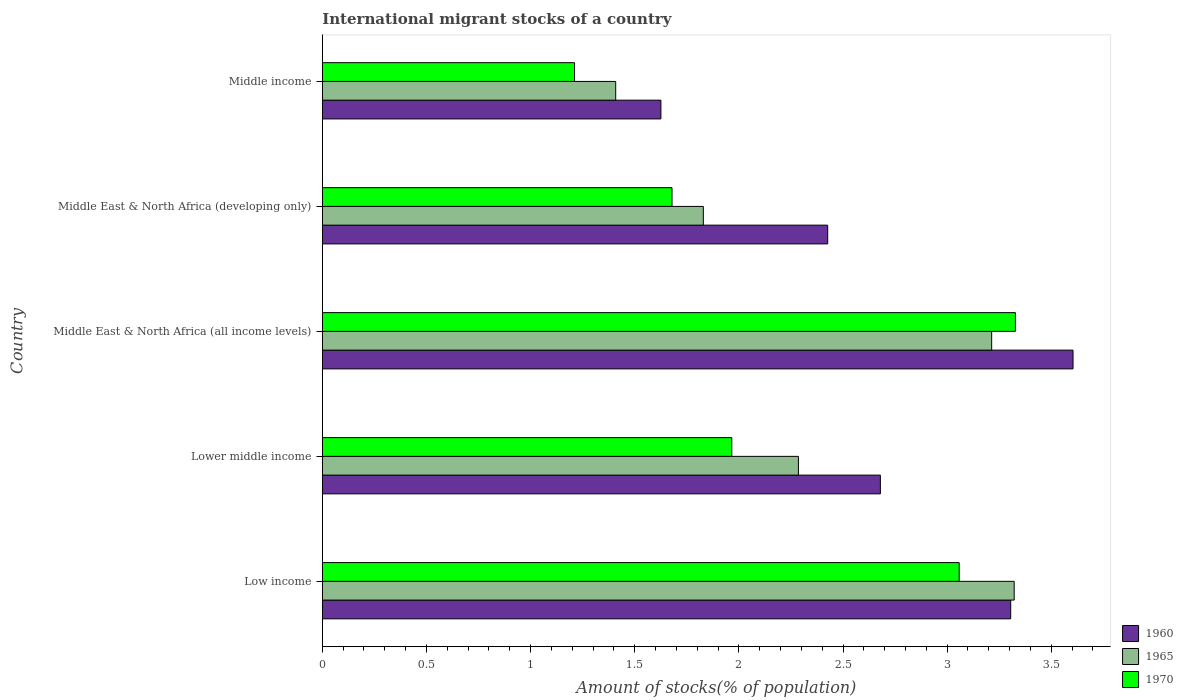How many bars are there on the 5th tick from the top?
Ensure brevity in your answer.  3. How many bars are there on the 2nd tick from the bottom?
Offer a terse response. 3. What is the label of the 2nd group of bars from the top?
Your answer should be compact. Middle East & North Africa (developing only). What is the amount of stocks in in 1965 in Low income?
Ensure brevity in your answer.  3.32. Across all countries, what is the maximum amount of stocks in in 1965?
Ensure brevity in your answer.  3.32. Across all countries, what is the minimum amount of stocks in in 1970?
Keep it short and to the point. 1.21. In which country was the amount of stocks in in 1965 maximum?
Ensure brevity in your answer.  Low income. In which country was the amount of stocks in in 1970 minimum?
Provide a short and direct response. Middle income. What is the total amount of stocks in in 1970 in the graph?
Make the answer very short. 11.24. What is the difference between the amount of stocks in in 1960 in Lower middle income and that in Middle income?
Your answer should be very brief. 1.05. What is the difference between the amount of stocks in in 1965 in Middle income and the amount of stocks in in 1960 in Lower middle income?
Your response must be concise. -1.27. What is the average amount of stocks in in 1965 per country?
Your answer should be very brief. 2.41. What is the difference between the amount of stocks in in 1960 and amount of stocks in in 1965 in Middle East & North Africa (developing only)?
Your answer should be very brief. 0.6. In how many countries, is the amount of stocks in in 1960 greater than 2 %?
Offer a very short reply. 4. What is the ratio of the amount of stocks in in 1970 in Low income to that in Middle income?
Your answer should be very brief. 2.53. Is the amount of stocks in in 1960 in Middle East & North Africa (developing only) less than that in Middle income?
Ensure brevity in your answer.  No. What is the difference between the highest and the second highest amount of stocks in in 1970?
Your answer should be compact. 0.27. What is the difference between the highest and the lowest amount of stocks in in 1960?
Offer a terse response. 1.98. Is the sum of the amount of stocks in in 1960 in Low income and Middle East & North Africa (all income levels) greater than the maximum amount of stocks in in 1970 across all countries?
Give a very brief answer. Yes. What does the 2nd bar from the top in Lower middle income represents?
Make the answer very short. 1965. What does the 1st bar from the bottom in Lower middle income represents?
Offer a very short reply. 1960. How many bars are there?
Provide a succinct answer. 15. Are all the bars in the graph horizontal?
Ensure brevity in your answer.  Yes. How many countries are there in the graph?
Provide a succinct answer. 5. What is the difference between two consecutive major ticks on the X-axis?
Keep it short and to the point. 0.5. Does the graph contain any zero values?
Provide a succinct answer. No. How many legend labels are there?
Your answer should be compact. 3. How are the legend labels stacked?
Make the answer very short. Vertical. What is the title of the graph?
Provide a succinct answer. International migrant stocks of a country. Does "1974" appear as one of the legend labels in the graph?
Offer a terse response. No. What is the label or title of the X-axis?
Ensure brevity in your answer.  Amount of stocks(% of population). What is the label or title of the Y-axis?
Your answer should be very brief. Country. What is the Amount of stocks(% of population) of 1960 in Low income?
Your response must be concise. 3.31. What is the Amount of stocks(% of population) of 1965 in Low income?
Offer a terse response. 3.32. What is the Amount of stocks(% of population) in 1970 in Low income?
Offer a terse response. 3.06. What is the Amount of stocks(% of population) in 1960 in Lower middle income?
Ensure brevity in your answer.  2.68. What is the Amount of stocks(% of population) of 1965 in Lower middle income?
Provide a succinct answer. 2.29. What is the Amount of stocks(% of population) of 1970 in Lower middle income?
Ensure brevity in your answer.  1.97. What is the Amount of stocks(% of population) in 1960 in Middle East & North Africa (all income levels)?
Your response must be concise. 3.6. What is the Amount of stocks(% of population) of 1965 in Middle East & North Africa (all income levels)?
Make the answer very short. 3.21. What is the Amount of stocks(% of population) in 1970 in Middle East & North Africa (all income levels)?
Your response must be concise. 3.33. What is the Amount of stocks(% of population) in 1960 in Middle East & North Africa (developing only)?
Keep it short and to the point. 2.43. What is the Amount of stocks(% of population) in 1965 in Middle East & North Africa (developing only)?
Give a very brief answer. 1.83. What is the Amount of stocks(% of population) in 1970 in Middle East & North Africa (developing only)?
Your answer should be compact. 1.68. What is the Amount of stocks(% of population) in 1960 in Middle income?
Give a very brief answer. 1.63. What is the Amount of stocks(% of population) of 1965 in Middle income?
Make the answer very short. 1.41. What is the Amount of stocks(% of population) in 1970 in Middle income?
Give a very brief answer. 1.21. Across all countries, what is the maximum Amount of stocks(% of population) in 1960?
Provide a succinct answer. 3.6. Across all countries, what is the maximum Amount of stocks(% of population) of 1965?
Your answer should be very brief. 3.32. Across all countries, what is the maximum Amount of stocks(% of population) of 1970?
Give a very brief answer. 3.33. Across all countries, what is the minimum Amount of stocks(% of population) of 1960?
Make the answer very short. 1.63. Across all countries, what is the minimum Amount of stocks(% of population) of 1965?
Keep it short and to the point. 1.41. Across all countries, what is the minimum Amount of stocks(% of population) of 1970?
Provide a short and direct response. 1.21. What is the total Amount of stocks(% of population) of 1960 in the graph?
Provide a short and direct response. 13.64. What is the total Amount of stocks(% of population) in 1965 in the graph?
Your answer should be compact. 12.06. What is the total Amount of stocks(% of population) in 1970 in the graph?
Keep it short and to the point. 11.24. What is the difference between the Amount of stocks(% of population) of 1960 in Low income and that in Lower middle income?
Offer a very short reply. 0.63. What is the difference between the Amount of stocks(% of population) in 1965 in Low income and that in Lower middle income?
Offer a terse response. 1.04. What is the difference between the Amount of stocks(% of population) of 1970 in Low income and that in Lower middle income?
Ensure brevity in your answer.  1.09. What is the difference between the Amount of stocks(% of population) in 1960 in Low income and that in Middle East & North Africa (all income levels)?
Keep it short and to the point. -0.3. What is the difference between the Amount of stocks(% of population) in 1965 in Low income and that in Middle East & North Africa (all income levels)?
Ensure brevity in your answer.  0.11. What is the difference between the Amount of stocks(% of population) in 1970 in Low income and that in Middle East & North Africa (all income levels)?
Keep it short and to the point. -0.27. What is the difference between the Amount of stocks(% of population) in 1960 in Low income and that in Middle East & North Africa (developing only)?
Your answer should be very brief. 0.88. What is the difference between the Amount of stocks(% of population) of 1965 in Low income and that in Middle East & North Africa (developing only)?
Your answer should be very brief. 1.49. What is the difference between the Amount of stocks(% of population) in 1970 in Low income and that in Middle East & North Africa (developing only)?
Offer a very short reply. 1.38. What is the difference between the Amount of stocks(% of population) in 1960 in Low income and that in Middle income?
Give a very brief answer. 1.68. What is the difference between the Amount of stocks(% of population) of 1965 in Low income and that in Middle income?
Make the answer very short. 1.91. What is the difference between the Amount of stocks(% of population) of 1970 in Low income and that in Middle income?
Your answer should be compact. 1.85. What is the difference between the Amount of stocks(% of population) of 1960 in Lower middle income and that in Middle East & North Africa (all income levels)?
Offer a terse response. -0.93. What is the difference between the Amount of stocks(% of population) in 1965 in Lower middle income and that in Middle East & North Africa (all income levels)?
Ensure brevity in your answer.  -0.93. What is the difference between the Amount of stocks(% of population) of 1970 in Lower middle income and that in Middle East & North Africa (all income levels)?
Offer a very short reply. -1.36. What is the difference between the Amount of stocks(% of population) in 1960 in Lower middle income and that in Middle East & North Africa (developing only)?
Provide a succinct answer. 0.25. What is the difference between the Amount of stocks(% of population) in 1965 in Lower middle income and that in Middle East & North Africa (developing only)?
Give a very brief answer. 0.46. What is the difference between the Amount of stocks(% of population) of 1970 in Lower middle income and that in Middle East & North Africa (developing only)?
Keep it short and to the point. 0.29. What is the difference between the Amount of stocks(% of population) in 1960 in Lower middle income and that in Middle income?
Give a very brief answer. 1.05. What is the difference between the Amount of stocks(% of population) in 1965 in Lower middle income and that in Middle income?
Make the answer very short. 0.88. What is the difference between the Amount of stocks(% of population) in 1970 in Lower middle income and that in Middle income?
Offer a terse response. 0.76. What is the difference between the Amount of stocks(% of population) in 1960 in Middle East & North Africa (all income levels) and that in Middle East & North Africa (developing only)?
Your answer should be compact. 1.18. What is the difference between the Amount of stocks(% of population) of 1965 in Middle East & North Africa (all income levels) and that in Middle East & North Africa (developing only)?
Offer a very short reply. 1.38. What is the difference between the Amount of stocks(% of population) of 1970 in Middle East & North Africa (all income levels) and that in Middle East & North Africa (developing only)?
Give a very brief answer. 1.65. What is the difference between the Amount of stocks(% of population) of 1960 in Middle East & North Africa (all income levels) and that in Middle income?
Give a very brief answer. 1.98. What is the difference between the Amount of stocks(% of population) in 1965 in Middle East & North Africa (all income levels) and that in Middle income?
Offer a very short reply. 1.81. What is the difference between the Amount of stocks(% of population) in 1970 in Middle East & North Africa (all income levels) and that in Middle income?
Ensure brevity in your answer.  2.12. What is the difference between the Amount of stocks(% of population) in 1960 in Middle East & North Africa (developing only) and that in Middle income?
Your response must be concise. 0.8. What is the difference between the Amount of stocks(% of population) in 1965 in Middle East & North Africa (developing only) and that in Middle income?
Your answer should be compact. 0.42. What is the difference between the Amount of stocks(% of population) in 1970 in Middle East & North Africa (developing only) and that in Middle income?
Provide a succinct answer. 0.47. What is the difference between the Amount of stocks(% of population) in 1960 in Low income and the Amount of stocks(% of population) in 1965 in Lower middle income?
Offer a very short reply. 1.02. What is the difference between the Amount of stocks(% of population) in 1960 in Low income and the Amount of stocks(% of population) in 1970 in Lower middle income?
Your answer should be very brief. 1.34. What is the difference between the Amount of stocks(% of population) in 1965 in Low income and the Amount of stocks(% of population) in 1970 in Lower middle income?
Provide a succinct answer. 1.36. What is the difference between the Amount of stocks(% of population) of 1960 in Low income and the Amount of stocks(% of population) of 1965 in Middle East & North Africa (all income levels)?
Provide a succinct answer. 0.09. What is the difference between the Amount of stocks(% of population) of 1960 in Low income and the Amount of stocks(% of population) of 1970 in Middle East & North Africa (all income levels)?
Offer a very short reply. -0.02. What is the difference between the Amount of stocks(% of population) of 1965 in Low income and the Amount of stocks(% of population) of 1970 in Middle East & North Africa (all income levels)?
Give a very brief answer. -0.01. What is the difference between the Amount of stocks(% of population) in 1960 in Low income and the Amount of stocks(% of population) in 1965 in Middle East & North Africa (developing only)?
Provide a succinct answer. 1.48. What is the difference between the Amount of stocks(% of population) in 1960 in Low income and the Amount of stocks(% of population) in 1970 in Middle East & North Africa (developing only)?
Provide a succinct answer. 1.63. What is the difference between the Amount of stocks(% of population) of 1965 in Low income and the Amount of stocks(% of population) of 1970 in Middle East & North Africa (developing only)?
Keep it short and to the point. 1.64. What is the difference between the Amount of stocks(% of population) in 1960 in Low income and the Amount of stocks(% of population) in 1965 in Middle income?
Provide a succinct answer. 1.9. What is the difference between the Amount of stocks(% of population) of 1960 in Low income and the Amount of stocks(% of population) of 1970 in Middle income?
Offer a terse response. 2.09. What is the difference between the Amount of stocks(% of population) in 1965 in Low income and the Amount of stocks(% of population) in 1970 in Middle income?
Provide a short and direct response. 2.11. What is the difference between the Amount of stocks(% of population) in 1960 in Lower middle income and the Amount of stocks(% of population) in 1965 in Middle East & North Africa (all income levels)?
Your answer should be very brief. -0.53. What is the difference between the Amount of stocks(% of population) of 1960 in Lower middle income and the Amount of stocks(% of population) of 1970 in Middle East & North Africa (all income levels)?
Provide a short and direct response. -0.65. What is the difference between the Amount of stocks(% of population) in 1965 in Lower middle income and the Amount of stocks(% of population) in 1970 in Middle East & North Africa (all income levels)?
Keep it short and to the point. -1.04. What is the difference between the Amount of stocks(% of population) of 1960 in Lower middle income and the Amount of stocks(% of population) of 1965 in Middle East & North Africa (developing only)?
Keep it short and to the point. 0.85. What is the difference between the Amount of stocks(% of population) in 1960 in Lower middle income and the Amount of stocks(% of population) in 1970 in Middle East & North Africa (developing only)?
Your response must be concise. 1. What is the difference between the Amount of stocks(% of population) in 1965 in Lower middle income and the Amount of stocks(% of population) in 1970 in Middle East & North Africa (developing only)?
Provide a succinct answer. 0.61. What is the difference between the Amount of stocks(% of population) of 1960 in Lower middle income and the Amount of stocks(% of population) of 1965 in Middle income?
Make the answer very short. 1.27. What is the difference between the Amount of stocks(% of population) in 1960 in Lower middle income and the Amount of stocks(% of population) in 1970 in Middle income?
Ensure brevity in your answer.  1.47. What is the difference between the Amount of stocks(% of population) in 1965 in Lower middle income and the Amount of stocks(% of population) in 1970 in Middle income?
Your response must be concise. 1.07. What is the difference between the Amount of stocks(% of population) of 1960 in Middle East & North Africa (all income levels) and the Amount of stocks(% of population) of 1965 in Middle East & North Africa (developing only)?
Provide a short and direct response. 1.78. What is the difference between the Amount of stocks(% of population) of 1960 in Middle East & North Africa (all income levels) and the Amount of stocks(% of population) of 1970 in Middle East & North Africa (developing only)?
Provide a succinct answer. 1.93. What is the difference between the Amount of stocks(% of population) in 1965 in Middle East & North Africa (all income levels) and the Amount of stocks(% of population) in 1970 in Middle East & North Africa (developing only)?
Offer a terse response. 1.53. What is the difference between the Amount of stocks(% of population) of 1960 in Middle East & North Africa (all income levels) and the Amount of stocks(% of population) of 1965 in Middle income?
Keep it short and to the point. 2.2. What is the difference between the Amount of stocks(% of population) in 1960 in Middle East & North Africa (all income levels) and the Amount of stocks(% of population) in 1970 in Middle income?
Offer a very short reply. 2.39. What is the difference between the Amount of stocks(% of population) of 1965 in Middle East & North Africa (all income levels) and the Amount of stocks(% of population) of 1970 in Middle income?
Your answer should be compact. 2. What is the difference between the Amount of stocks(% of population) in 1960 in Middle East & North Africa (developing only) and the Amount of stocks(% of population) in 1970 in Middle income?
Your response must be concise. 1.22. What is the difference between the Amount of stocks(% of population) of 1965 in Middle East & North Africa (developing only) and the Amount of stocks(% of population) of 1970 in Middle income?
Offer a very short reply. 0.62. What is the average Amount of stocks(% of population) in 1960 per country?
Ensure brevity in your answer.  2.73. What is the average Amount of stocks(% of population) in 1965 per country?
Offer a very short reply. 2.41. What is the average Amount of stocks(% of population) of 1970 per country?
Your response must be concise. 2.25. What is the difference between the Amount of stocks(% of population) of 1960 and Amount of stocks(% of population) of 1965 in Low income?
Offer a very short reply. -0.02. What is the difference between the Amount of stocks(% of population) of 1960 and Amount of stocks(% of population) of 1970 in Low income?
Make the answer very short. 0.25. What is the difference between the Amount of stocks(% of population) in 1965 and Amount of stocks(% of population) in 1970 in Low income?
Make the answer very short. 0.26. What is the difference between the Amount of stocks(% of population) of 1960 and Amount of stocks(% of population) of 1965 in Lower middle income?
Offer a very short reply. 0.39. What is the difference between the Amount of stocks(% of population) of 1960 and Amount of stocks(% of population) of 1970 in Lower middle income?
Keep it short and to the point. 0.71. What is the difference between the Amount of stocks(% of population) of 1965 and Amount of stocks(% of population) of 1970 in Lower middle income?
Offer a terse response. 0.32. What is the difference between the Amount of stocks(% of population) in 1960 and Amount of stocks(% of population) in 1965 in Middle East & North Africa (all income levels)?
Provide a short and direct response. 0.39. What is the difference between the Amount of stocks(% of population) of 1960 and Amount of stocks(% of population) of 1970 in Middle East & North Africa (all income levels)?
Offer a very short reply. 0.28. What is the difference between the Amount of stocks(% of population) of 1965 and Amount of stocks(% of population) of 1970 in Middle East & North Africa (all income levels)?
Offer a terse response. -0.11. What is the difference between the Amount of stocks(% of population) of 1960 and Amount of stocks(% of population) of 1965 in Middle East & North Africa (developing only)?
Make the answer very short. 0.6. What is the difference between the Amount of stocks(% of population) of 1960 and Amount of stocks(% of population) of 1970 in Middle East & North Africa (developing only)?
Keep it short and to the point. 0.75. What is the difference between the Amount of stocks(% of population) in 1965 and Amount of stocks(% of population) in 1970 in Middle East & North Africa (developing only)?
Provide a short and direct response. 0.15. What is the difference between the Amount of stocks(% of population) in 1960 and Amount of stocks(% of population) in 1965 in Middle income?
Make the answer very short. 0.22. What is the difference between the Amount of stocks(% of population) in 1960 and Amount of stocks(% of population) in 1970 in Middle income?
Make the answer very short. 0.41. What is the difference between the Amount of stocks(% of population) in 1965 and Amount of stocks(% of population) in 1970 in Middle income?
Keep it short and to the point. 0.2. What is the ratio of the Amount of stocks(% of population) in 1960 in Low income to that in Lower middle income?
Provide a short and direct response. 1.23. What is the ratio of the Amount of stocks(% of population) in 1965 in Low income to that in Lower middle income?
Provide a succinct answer. 1.45. What is the ratio of the Amount of stocks(% of population) of 1970 in Low income to that in Lower middle income?
Your answer should be very brief. 1.56. What is the ratio of the Amount of stocks(% of population) in 1960 in Low income to that in Middle East & North Africa (all income levels)?
Offer a very short reply. 0.92. What is the ratio of the Amount of stocks(% of population) of 1965 in Low income to that in Middle East & North Africa (all income levels)?
Provide a short and direct response. 1.03. What is the ratio of the Amount of stocks(% of population) of 1970 in Low income to that in Middle East & North Africa (all income levels)?
Your response must be concise. 0.92. What is the ratio of the Amount of stocks(% of population) in 1960 in Low income to that in Middle East & North Africa (developing only)?
Make the answer very short. 1.36. What is the ratio of the Amount of stocks(% of population) of 1965 in Low income to that in Middle East & North Africa (developing only)?
Offer a terse response. 1.82. What is the ratio of the Amount of stocks(% of population) of 1970 in Low income to that in Middle East & North Africa (developing only)?
Make the answer very short. 1.82. What is the ratio of the Amount of stocks(% of population) of 1960 in Low income to that in Middle income?
Your response must be concise. 2.03. What is the ratio of the Amount of stocks(% of population) of 1965 in Low income to that in Middle income?
Your response must be concise. 2.36. What is the ratio of the Amount of stocks(% of population) in 1970 in Low income to that in Middle income?
Your response must be concise. 2.52. What is the ratio of the Amount of stocks(% of population) of 1960 in Lower middle income to that in Middle East & North Africa (all income levels)?
Make the answer very short. 0.74. What is the ratio of the Amount of stocks(% of population) in 1965 in Lower middle income to that in Middle East & North Africa (all income levels)?
Keep it short and to the point. 0.71. What is the ratio of the Amount of stocks(% of population) of 1970 in Lower middle income to that in Middle East & North Africa (all income levels)?
Keep it short and to the point. 0.59. What is the ratio of the Amount of stocks(% of population) of 1960 in Lower middle income to that in Middle East & North Africa (developing only)?
Give a very brief answer. 1.1. What is the ratio of the Amount of stocks(% of population) in 1965 in Lower middle income to that in Middle East & North Africa (developing only)?
Give a very brief answer. 1.25. What is the ratio of the Amount of stocks(% of population) in 1970 in Lower middle income to that in Middle East & North Africa (developing only)?
Offer a terse response. 1.17. What is the ratio of the Amount of stocks(% of population) in 1960 in Lower middle income to that in Middle income?
Ensure brevity in your answer.  1.65. What is the ratio of the Amount of stocks(% of population) of 1965 in Lower middle income to that in Middle income?
Provide a short and direct response. 1.62. What is the ratio of the Amount of stocks(% of population) of 1970 in Lower middle income to that in Middle income?
Provide a short and direct response. 1.62. What is the ratio of the Amount of stocks(% of population) of 1960 in Middle East & North Africa (all income levels) to that in Middle East & North Africa (developing only)?
Offer a very short reply. 1.49. What is the ratio of the Amount of stocks(% of population) of 1965 in Middle East & North Africa (all income levels) to that in Middle East & North Africa (developing only)?
Your answer should be very brief. 1.76. What is the ratio of the Amount of stocks(% of population) in 1970 in Middle East & North Africa (all income levels) to that in Middle East & North Africa (developing only)?
Provide a short and direct response. 1.98. What is the ratio of the Amount of stocks(% of population) of 1960 in Middle East & North Africa (all income levels) to that in Middle income?
Your response must be concise. 2.22. What is the ratio of the Amount of stocks(% of population) of 1965 in Middle East & North Africa (all income levels) to that in Middle income?
Offer a terse response. 2.28. What is the ratio of the Amount of stocks(% of population) in 1970 in Middle East & North Africa (all income levels) to that in Middle income?
Provide a short and direct response. 2.75. What is the ratio of the Amount of stocks(% of population) of 1960 in Middle East & North Africa (developing only) to that in Middle income?
Provide a succinct answer. 1.49. What is the ratio of the Amount of stocks(% of population) of 1965 in Middle East & North Africa (developing only) to that in Middle income?
Your answer should be compact. 1.3. What is the ratio of the Amount of stocks(% of population) in 1970 in Middle East & North Africa (developing only) to that in Middle income?
Your response must be concise. 1.39. What is the difference between the highest and the second highest Amount of stocks(% of population) of 1960?
Your answer should be very brief. 0.3. What is the difference between the highest and the second highest Amount of stocks(% of population) in 1965?
Your response must be concise. 0.11. What is the difference between the highest and the second highest Amount of stocks(% of population) of 1970?
Give a very brief answer. 0.27. What is the difference between the highest and the lowest Amount of stocks(% of population) in 1960?
Provide a succinct answer. 1.98. What is the difference between the highest and the lowest Amount of stocks(% of population) in 1965?
Make the answer very short. 1.91. What is the difference between the highest and the lowest Amount of stocks(% of population) in 1970?
Keep it short and to the point. 2.12. 